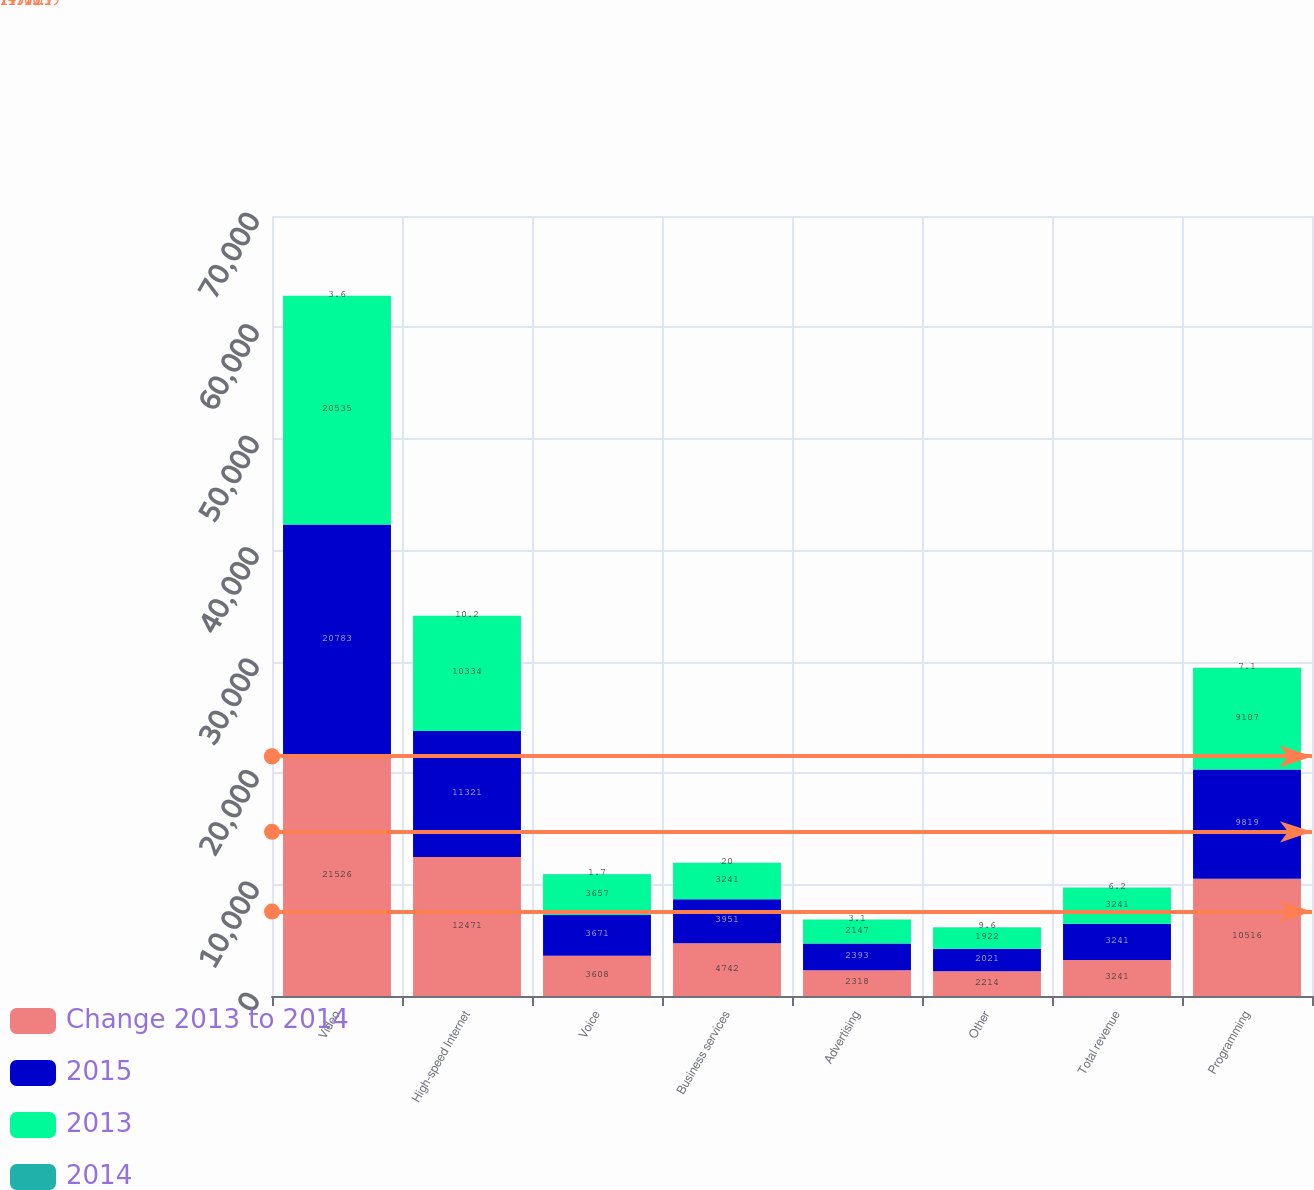Convert chart. <chart><loc_0><loc_0><loc_500><loc_500><stacked_bar_chart><ecel><fcel>Video<fcel>High-speed Internet<fcel>Voice<fcel>Business services<fcel>Advertising<fcel>Other<fcel>Total revenue<fcel>Programming<nl><fcel>Change 2013 to 2014<fcel>21526<fcel>12471<fcel>3608<fcel>4742<fcel>2318<fcel>2214<fcel>3241<fcel>10516<nl><fcel>2015<fcel>20783<fcel>11321<fcel>3671<fcel>3951<fcel>2393<fcel>2021<fcel>3241<fcel>9819<nl><fcel>2013<fcel>20535<fcel>10334<fcel>3657<fcel>3241<fcel>2147<fcel>1922<fcel>3241<fcel>9107<nl><fcel>2014<fcel>3.6<fcel>10.2<fcel>1.7<fcel>20<fcel>3.1<fcel>9.6<fcel>6.2<fcel>7.1<nl></chart> 